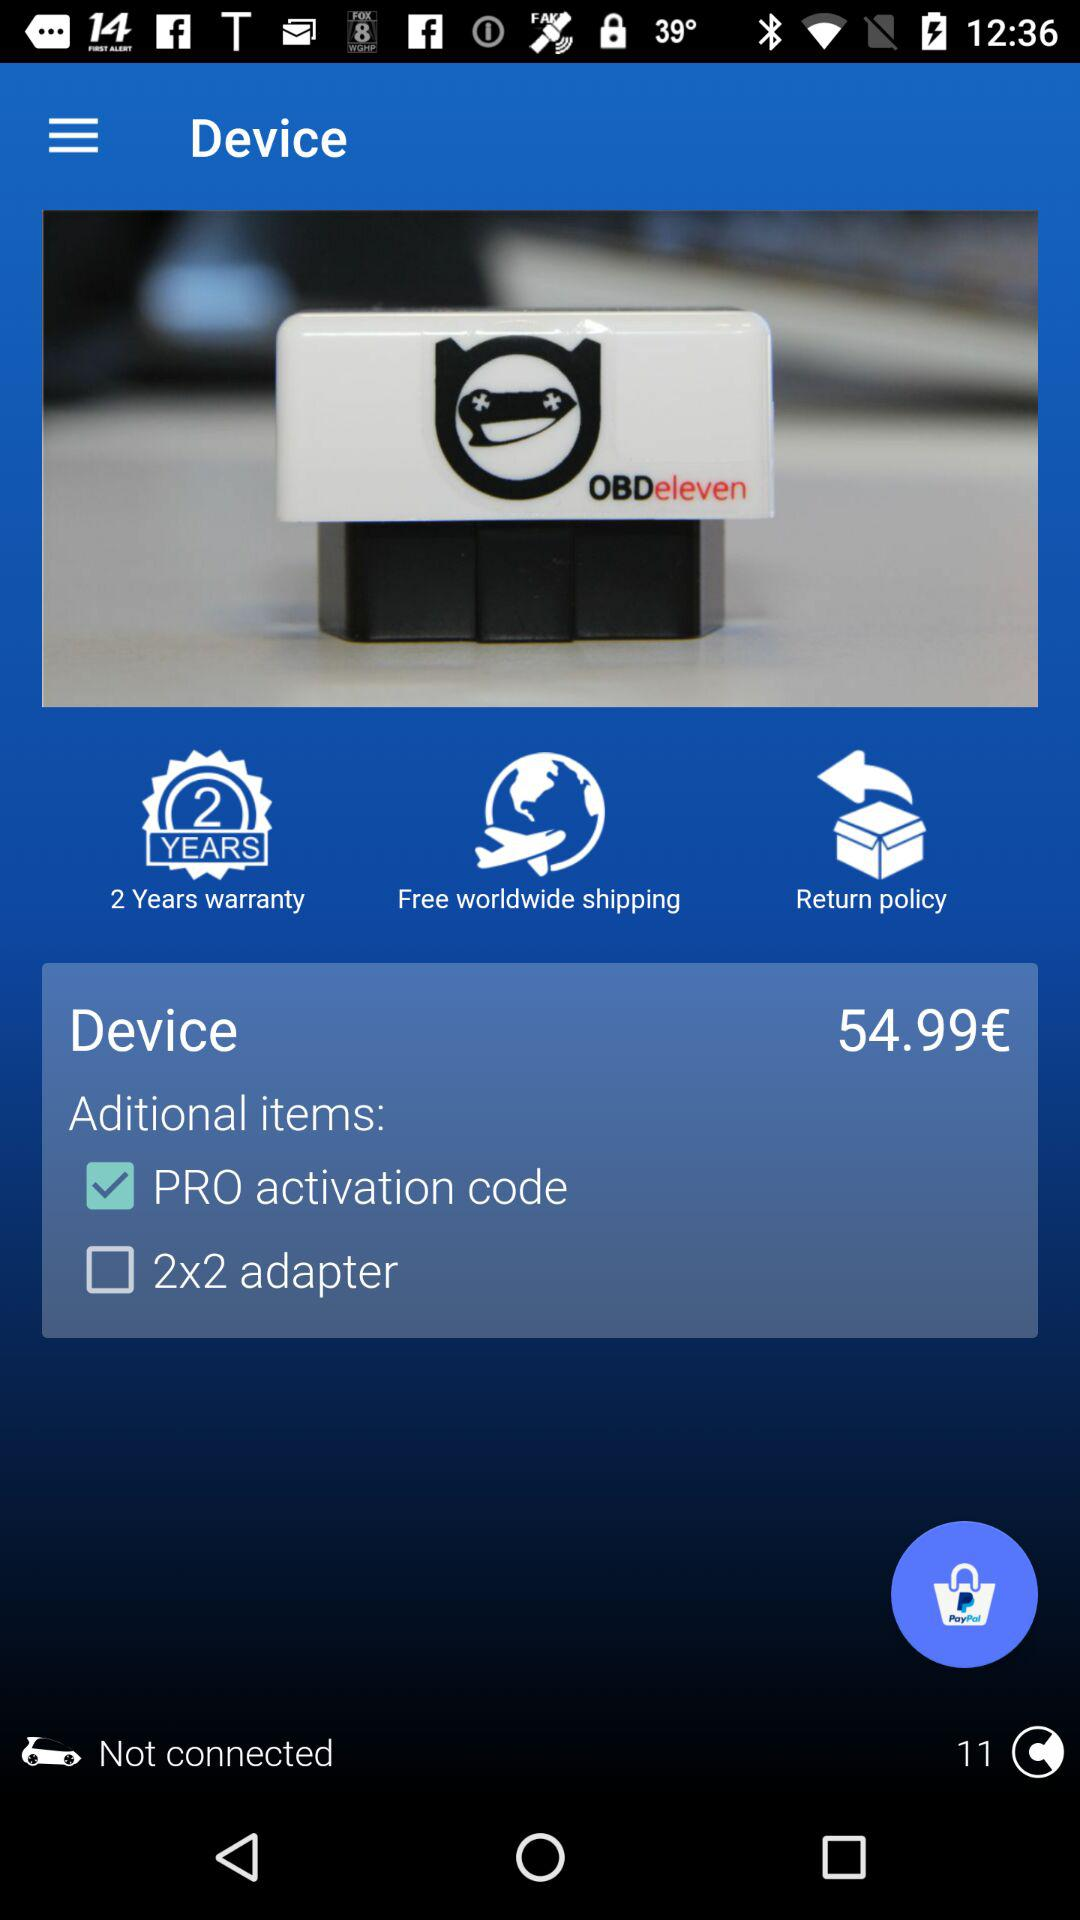What is the device name? The device name is "OBDeleven". 